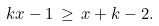Convert formula to latex. <formula><loc_0><loc_0><loc_500><loc_500>k x - 1 \, \geq \, x + k - 2 .</formula> 